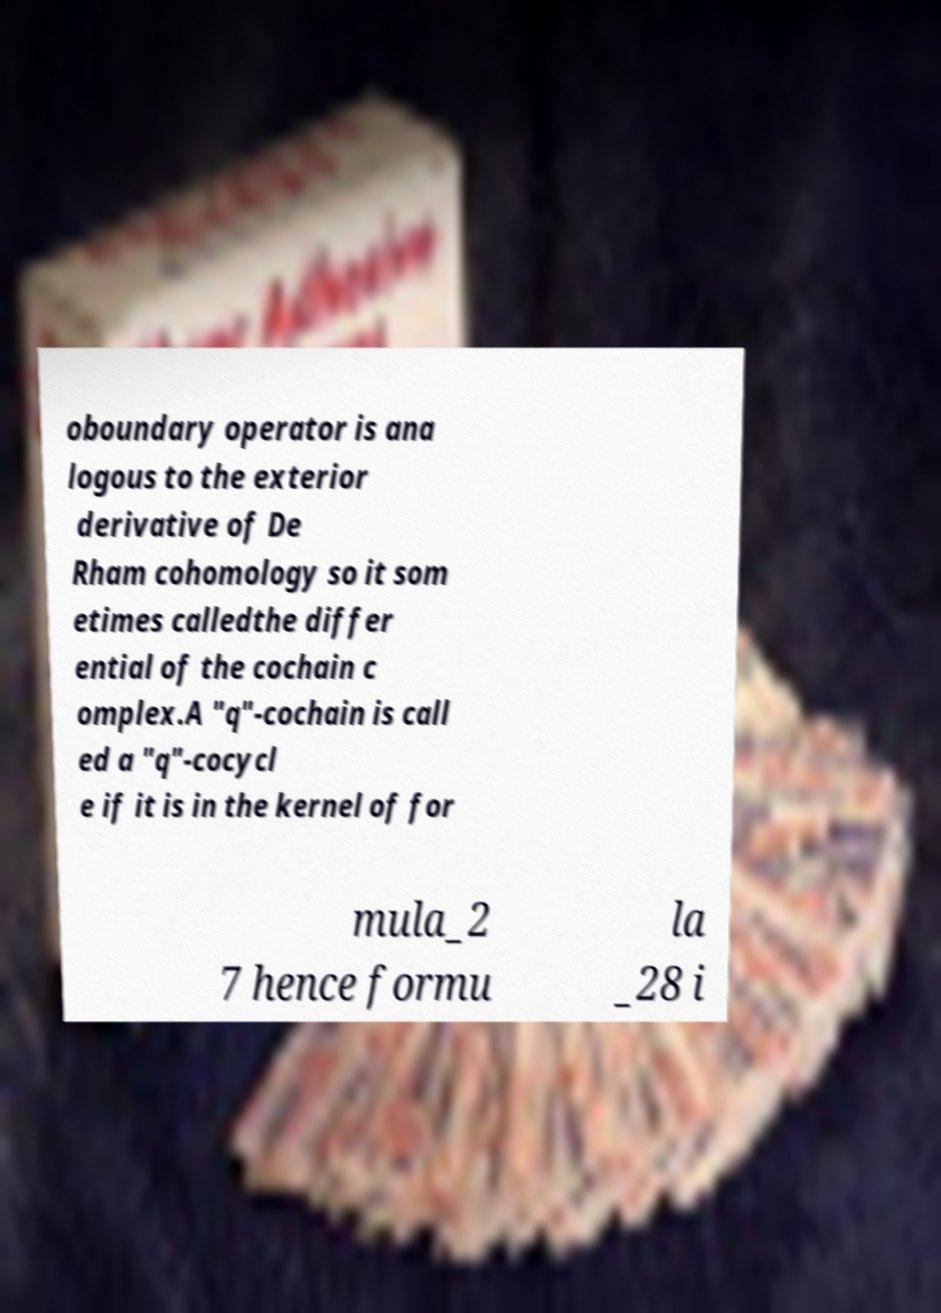There's text embedded in this image that I need extracted. Can you transcribe it verbatim? oboundary operator is ana logous to the exterior derivative of De Rham cohomology so it som etimes calledthe differ ential of the cochain c omplex.A "q"-cochain is call ed a "q"-cocycl e if it is in the kernel of for mula_2 7 hence formu la _28 i 